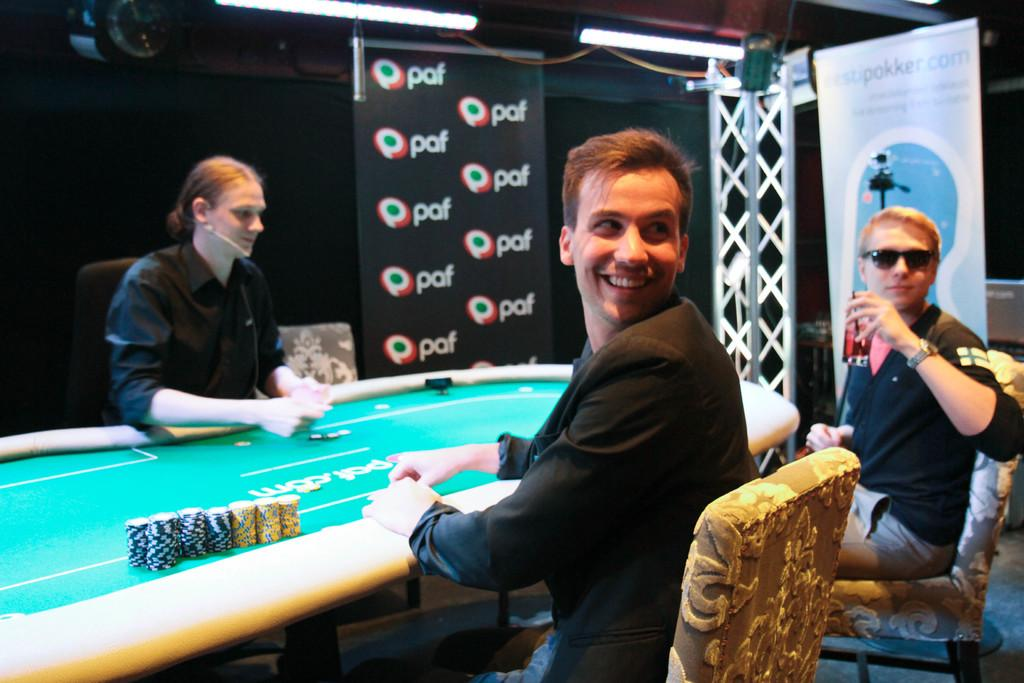What are the people in the image doing? The people in the image are sitting. Where are the people sitting in relation to each other? The people are surrounding a table. What else can be seen in the image besides the people sitting? There is a banner visible in the image. Can you tell me how many dinosaurs are present in the image? There are no dinosaurs present in the image. What type of volcano can be seen erupting in the background of the image? There is no volcano present in the image. 